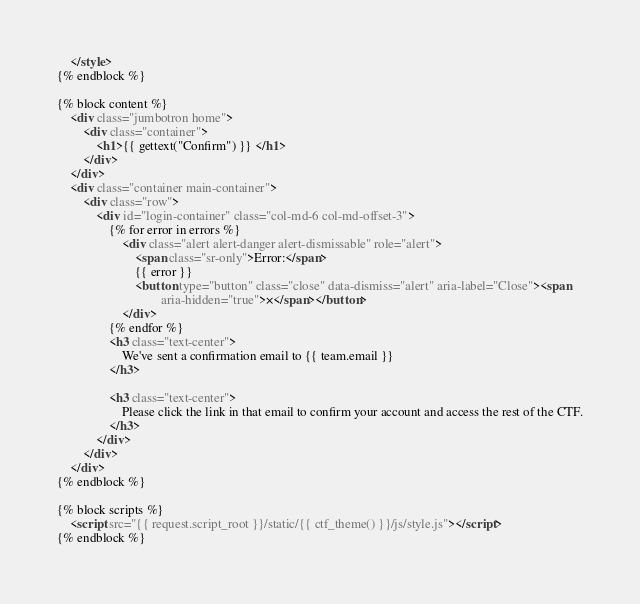<code> <loc_0><loc_0><loc_500><loc_500><_HTML_>    </style>
{% endblock %}

{% block content %}
    <div class="jumbotron home">
        <div class="container">
            <h1>{{ gettext("Confirm") }} </h1>
        </div>
    </div>
    <div class="container main-container">
        <div class="row">
            <div id="login-container" class="col-md-6 col-md-offset-3">
                {% for error in errors %}
                    <div class="alert alert-danger alert-dismissable" role="alert">
                        <span class="sr-only">Error:</span>
                        {{ error }}
                        <button type="button" class="close" data-dismiss="alert" aria-label="Close"><span
                                aria-hidden="true">×</span></button>
                    </div>
                {% endfor %}
                <h3 class="text-center">
                    We've sent a confirmation email to {{ team.email }}
                </h3>

                <h3 class="text-center">
                    Please click the link in that email to confirm your account and access the rest of the CTF.
                </h3>
            </div>
        </div>
    </div>
{% endblock %}

{% block scripts %}
    <script src="{{ request.script_root }}/static/{{ ctf_theme() }}/js/style.js"></script>
{% endblock %}
</code> 